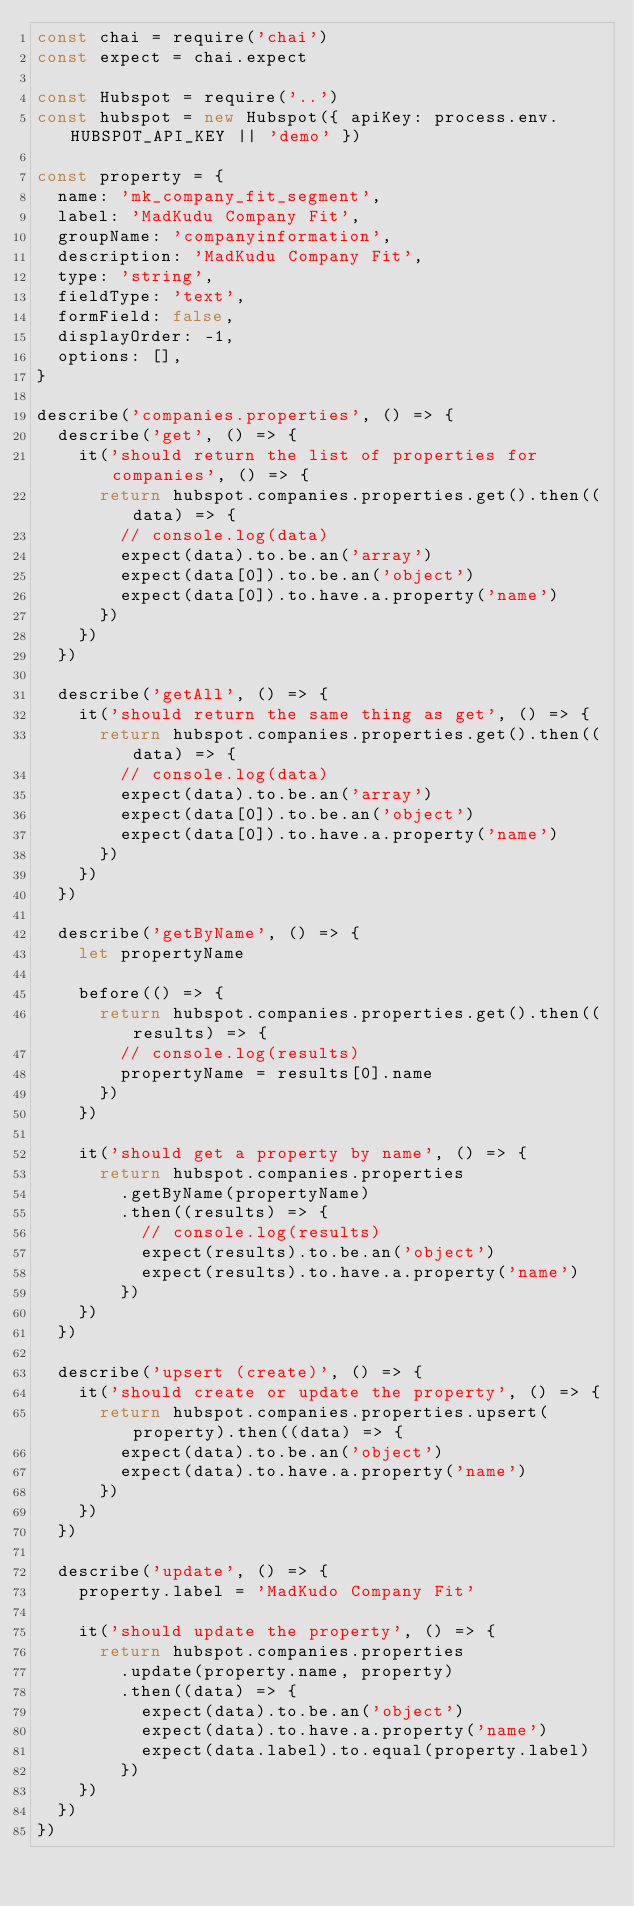<code> <loc_0><loc_0><loc_500><loc_500><_JavaScript_>const chai = require('chai')
const expect = chai.expect

const Hubspot = require('..')
const hubspot = new Hubspot({ apiKey: process.env.HUBSPOT_API_KEY || 'demo' })

const property = {
  name: 'mk_company_fit_segment',
  label: 'MadKudu Company Fit',
  groupName: 'companyinformation',
  description: 'MadKudu Company Fit',
  type: 'string',
  fieldType: 'text',
  formField: false,
  displayOrder: -1,
  options: [],
}

describe('companies.properties', () => {
  describe('get', () => {
    it('should return the list of properties for companies', () => {
      return hubspot.companies.properties.get().then((data) => {
        // console.log(data)
        expect(data).to.be.an('array')
        expect(data[0]).to.be.an('object')
        expect(data[0]).to.have.a.property('name')
      })
    })
  })

  describe('getAll', () => {
    it('should return the same thing as get', () => {
      return hubspot.companies.properties.get().then((data) => {
        // console.log(data)
        expect(data).to.be.an('array')
        expect(data[0]).to.be.an('object')
        expect(data[0]).to.have.a.property('name')
      })
    })
  })

  describe('getByName', () => {
    let propertyName

    before(() => {
      return hubspot.companies.properties.get().then((results) => {
        // console.log(results)
        propertyName = results[0].name
      })
    })

    it('should get a property by name', () => {
      return hubspot.companies.properties
        .getByName(propertyName)
        .then((results) => {
          // console.log(results)
          expect(results).to.be.an('object')
          expect(results).to.have.a.property('name')
        })
    })
  })

  describe('upsert (create)', () => {
    it('should create or update the property', () => {
      return hubspot.companies.properties.upsert(property).then((data) => {
        expect(data).to.be.an('object')
        expect(data).to.have.a.property('name')
      })
    })
  })

  describe('update', () => {
    property.label = 'MadKudo Company Fit'

    it('should update the property', () => {
      return hubspot.companies.properties
        .update(property.name, property)
        .then((data) => {
          expect(data).to.be.an('object')
          expect(data).to.have.a.property('name')
          expect(data.label).to.equal(property.label)
        })
    })
  })
})
</code> 